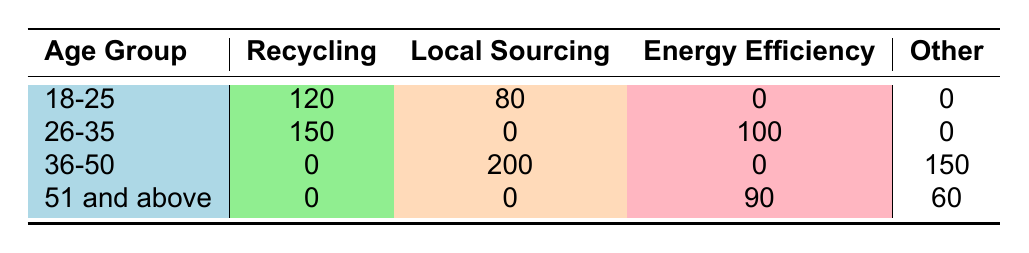What is the count of guests aged 26-35 who participated in the Recycling Program? In the table, under the age group 26-35, the recycling program has a count of 150.
Answer: 150 How many guests aged 36-50 engaged in Local Sourcing? The table shows that for the age group 36-50, the count for Local Sourcing is 200.
Answer: 200 What is the total number of guests who adopted Energy Efficiency practices across all age groups? Adding the counts for Energy Efficiency: 0 (18-25) + 100 (26-35) + 0 (36-50) + 90 (51 and above) equals 190.
Answer: 190 Did any guests aged 18-25 adopt the Energy Efficiency practice? Referring to the table, the energy efficiency row under age group 18-25 has a count of 0, indicating no guests participated.
Answer: No Which age group had the highest number of guests engaged in the Recycling Program? The count for the Recycling Program is 120 for age group 18-25 and 150 for age group 26-35, making 26-35 the highest.
Answer: 26-35 How does the total count of guests adopting Local Sourcing compare to those adopting Water Conservation? The total for Local Sourcing is 200 (36-50), while for Water Conservation is 150 (36-50). Thus, Local Sourcing is greater.
Answer: Local Sourcing is greater What percentage of guests aged 51 and above engaged in Community Engagement? The count for Community Engagement is 60 out of a total of 150 (90 for Energy Efficiency + 60 for Community Engagement). The percentage is (60/150) * 100 = 40%.
Answer: 40% Is the count of guests participating in Water Conservation higher than that in Local Sourcing? From the table, Water Conservation has a count of 150 while Local Sourcing has a count of 200. This indicates Water Conservation is lower.
Answer: No Which sustainability practice had the least number of participants among all age groups? The table indicates that both the Recycling Program and Energy Efficiency have no participants in the age group 36-50, but Energy Efficiency has counts in other age groups. Therefore, the least is Recycling in 36-50.
Answer: Recycling in 36-50 